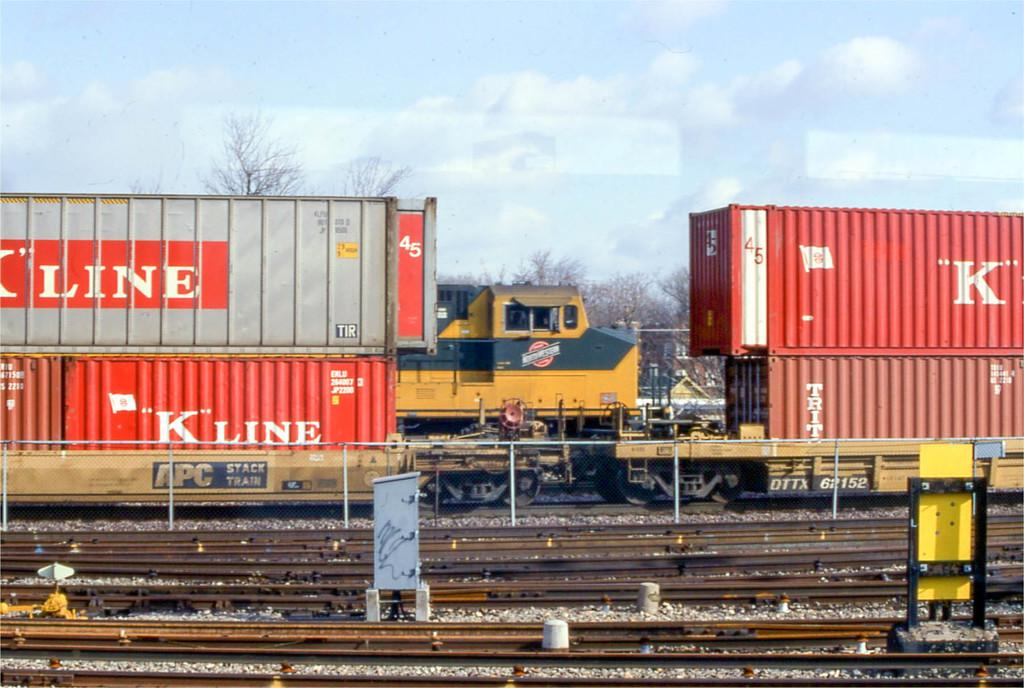What type of transportation infrastructure is visible in the image? There are railway tracks in the image. What other objects can be seen near the railway tracks? Stones, boards, and a fence are visible in the image. What is moving along the railway tracks in the image? Trains are observable in the image. What can be seen in the background of the image? There are trees, a building, and the sky visible in the background of the image. What type of bell can be heard ringing in the image? There is no bell present or audible in the image. What is being stored in the sack that is visible in the image? There is no sack present in the image. 